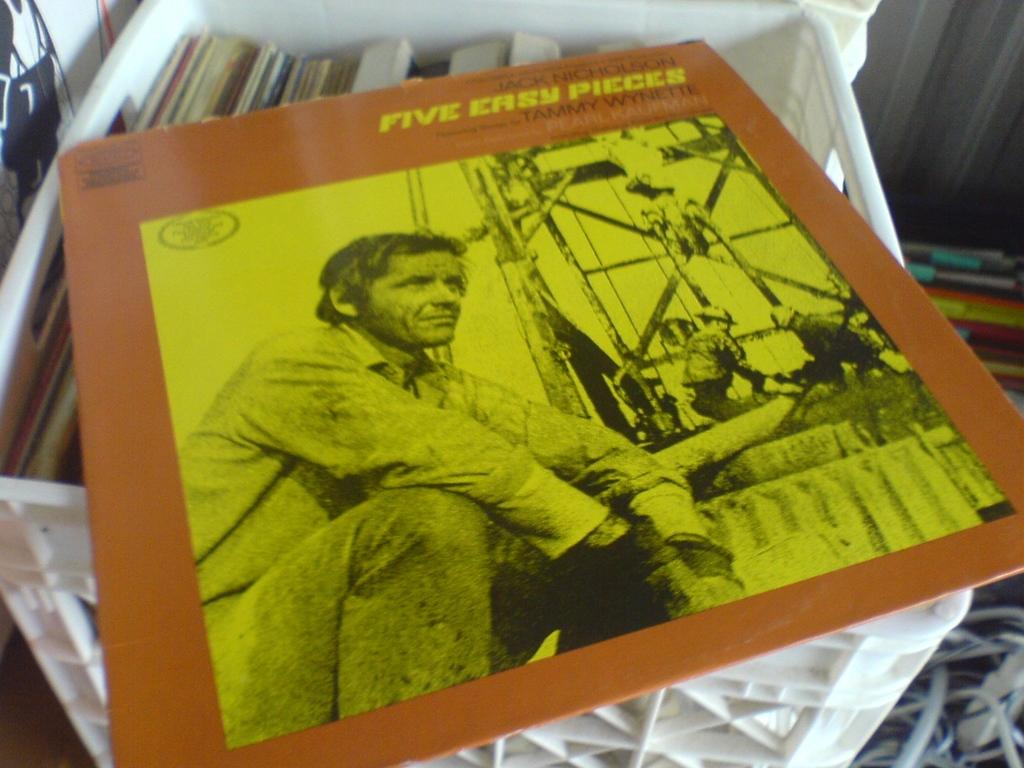<image>
Provide a brief description of the given image. A record with the title 5 easy pieces sits on top of a crate. 